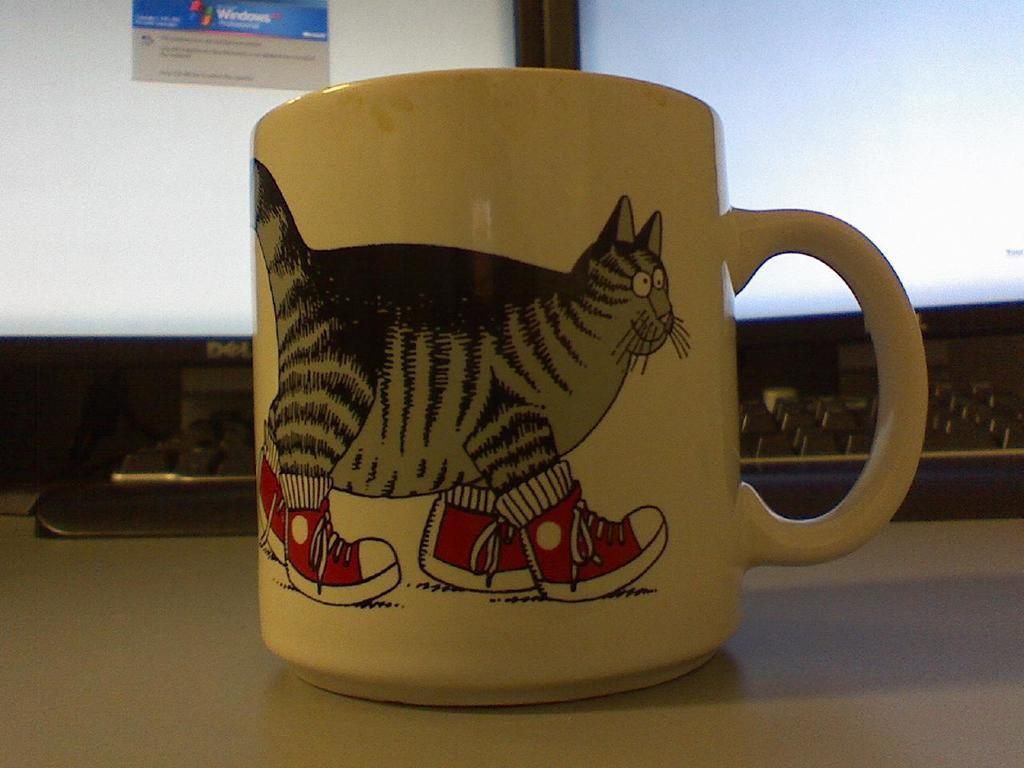What is depicted on the cup in the image? There is a painting on the cup in the image. Where is the cup located? The cup is on a surface in the image. What electronic device is present in the image? There is a keyboard and a computer in the image. How many legs does the ball have in the image? There is no ball present in the image, so it is not possible to determine how many legs it might have. 